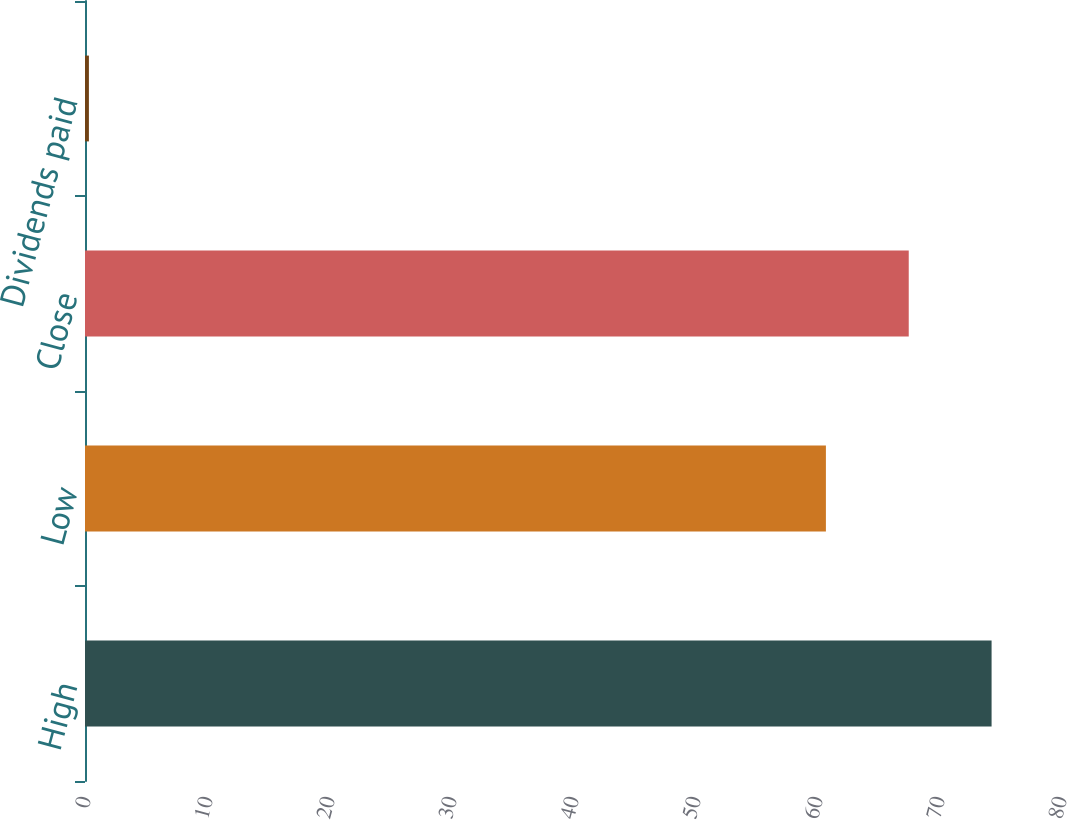Convert chart. <chart><loc_0><loc_0><loc_500><loc_500><bar_chart><fcel>High<fcel>Low<fcel>Close<fcel>Dividends paid<nl><fcel>74.31<fcel>60.73<fcel>67.52<fcel>0.32<nl></chart> 